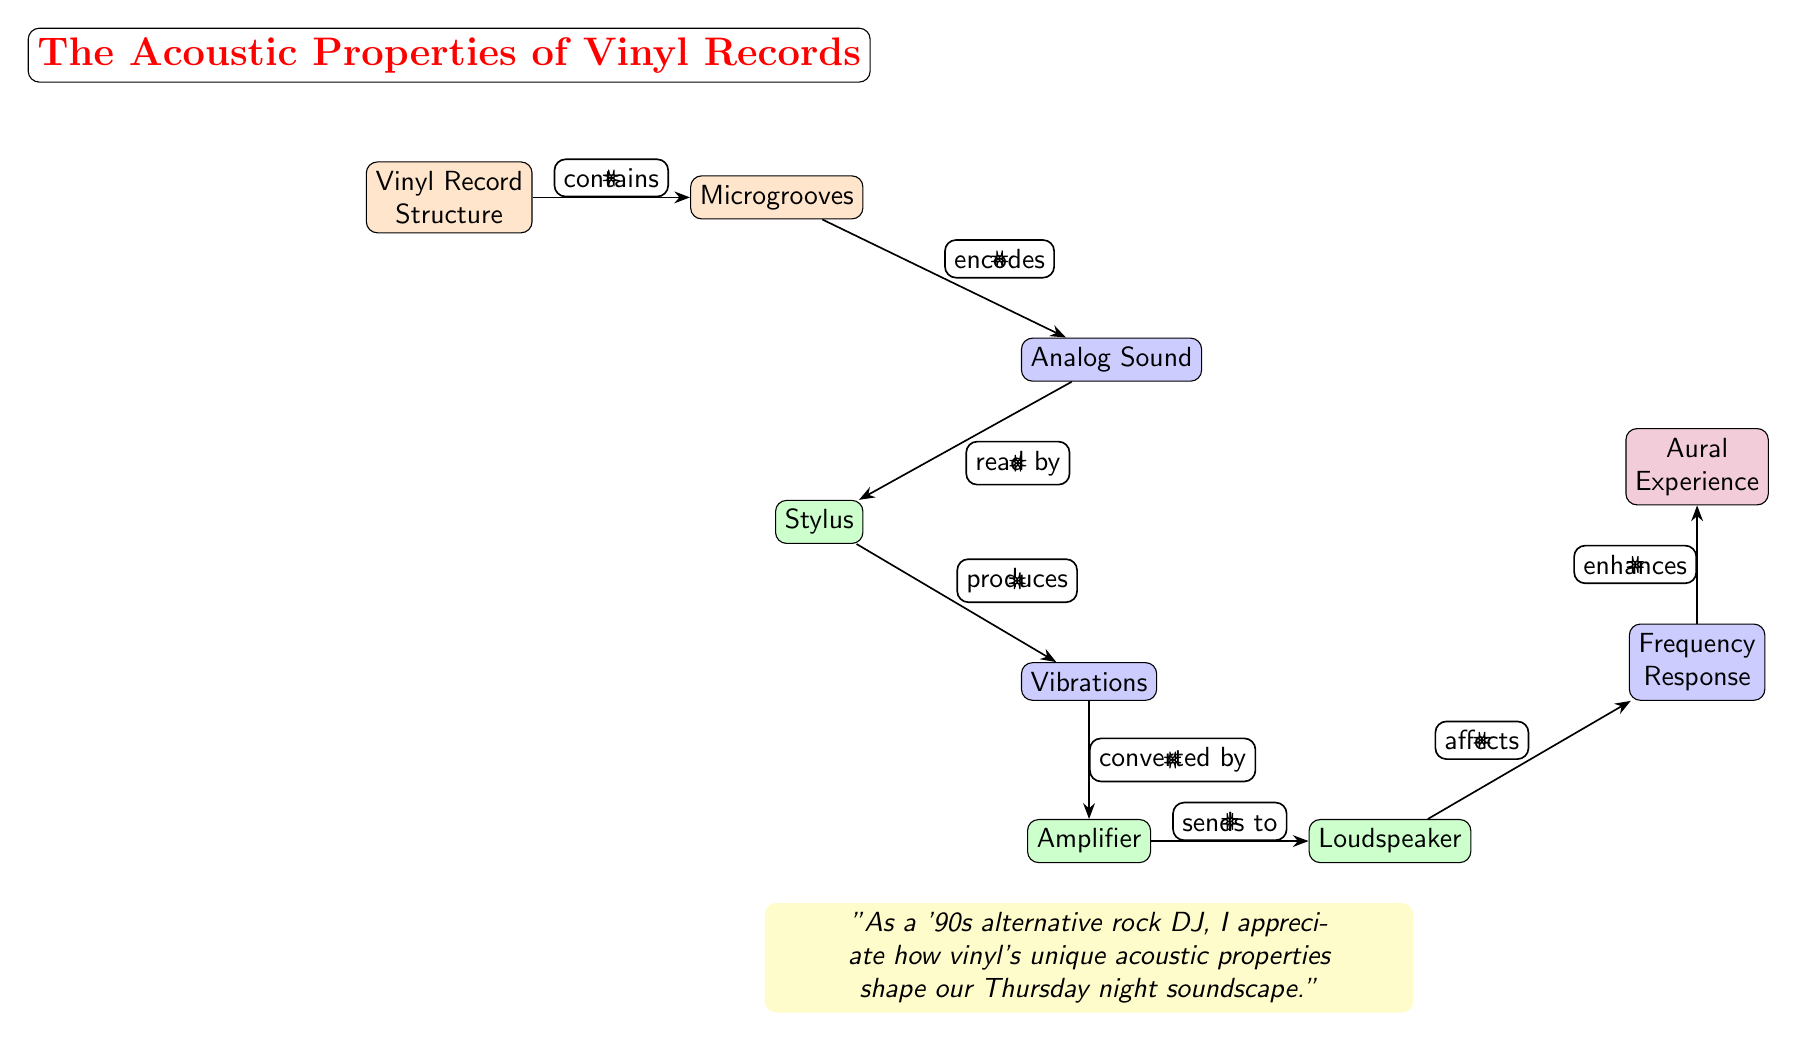What is the primary structure of the diagram? The diagram explicitly identifies the "Vinyl Record Structure" as the primary component at the top, indicating it is the basis for the acoustic properties discussed.
Answer: Vinyl Record Structure How many nodes are present in the diagram? Counting each labeled box in the diagram, including the title node and the detail boxes, there are nine distinct nodes present.
Answer: 9 What does the "Microgrooves" node do to "Analog Sound"? According to the diagram, "Microgrooves" directly "encodes" the "Analog Sound," signifying that the grooves directly contribute to the creation of sound.
Answer: encodes What component reads the sound from the vinyl? The diagram clearly states that the "Stylus" is the component that "reads" the sound from the vinyl record, highlighting its crucial role in the process.
Answer: Stylus What does the "Amplifier" do to the "Vibrations"? The diagram indicates that the "Amplifier" "converts" the vibrations produced by the "Stylus," illustrating the flow of sound enhancement in the system.
Answer: converts How does the "Loudspeaker" affect "Frequency Response"? Based on the diagram, the "Loudspeaker" "affects" the "Frequency Response," which suggests that it plays a role in shaping the sound quality that is produced.
Answer: affects What is the final element that is enhanced according to the diagram? As per the flow of interaction in the diagram, "Aural Experience" is indicated to be enhanced by the preceding components, representing the culmination of the audio process.
Answer: Aural Experience What is the color used for the "Equipment" nodes? The diagram uses a green color for the "Equipment" nodes, distinctly categorizing them for better visual understanding within the flow of the diagram.
Answer: green What is the relationship between "Vibrations" and "Amplifier"? The diagram shows that "Vibrations" are "converted by" the "Amplifier," indicating a direct interaction where vibrations are transformed into audio signals by the amplifier.
Answer: converted by 